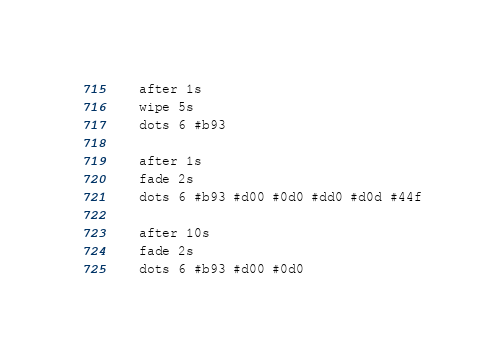Convert code to text. <code><loc_0><loc_0><loc_500><loc_500><_Lisp_>    after 1s
    wipe 5s
    dots 6 #b93

    after 1s
    fade 2s
    dots 6 #b93 #d00 #0d0 #dd0 #d0d #44f

    after 10s
    fade 2s
    dots 6 #b93 #d00 #0d0
</code> 